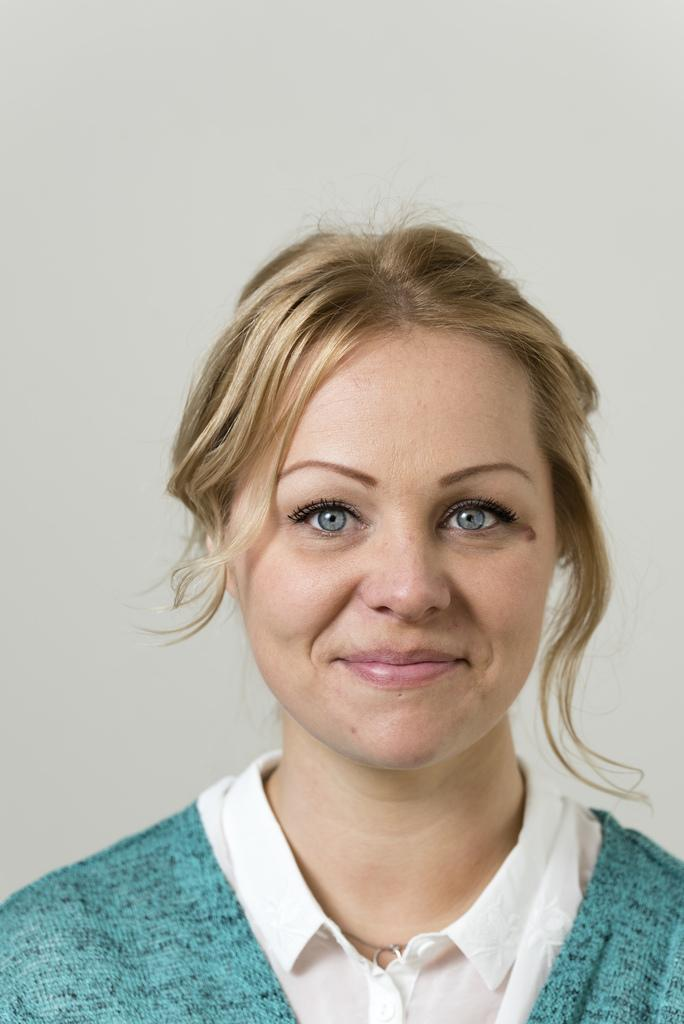Who is the main subject in the image? There is a lady in the center of the image. What is the lady doing in the image? The lady is smiling. What can be seen in the background of the image? There is a wall in the background of the image. How many apples are on the crib in the image? There is no crib or apples present in the image. What type of coast can be seen in the background of the image? There is no coast visible in the image; it features a lady smiling in the center and a wall in the background. 